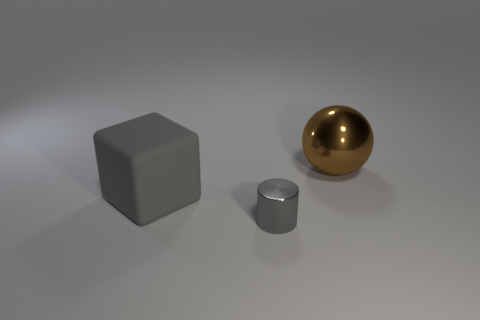Add 2 tiny blue balls. How many objects exist? 5 Subtract 1 cylinders. How many cylinders are left? 0 Subtract all brown cylinders. Subtract all blue cubes. How many cylinders are left? 1 Subtract all green matte cylinders. Subtract all shiny cylinders. How many objects are left? 2 Add 3 large blocks. How many large blocks are left? 4 Add 3 big gray rubber blocks. How many big gray rubber blocks exist? 4 Subtract 0 red balls. How many objects are left? 3 Subtract all balls. How many objects are left? 2 